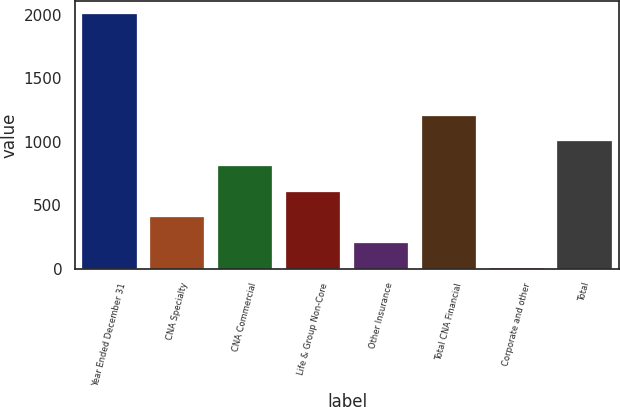<chart> <loc_0><loc_0><loc_500><loc_500><bar_chart><fcel>Year Ended December 31<fcel>CNA Specialty<fcel>CNA Commercial<fcel>Life & Group Non-Core<fcel>Other Insurance<fcel>Total CNA Financial<fcel>Corporate and other<fcel>Total<nl><fcel>2009<fcel>405<fcel>806<fcel>605.5<fcel>204.5<fcel>1207<fcel>4<fcel>1006.5<nl></chart> 